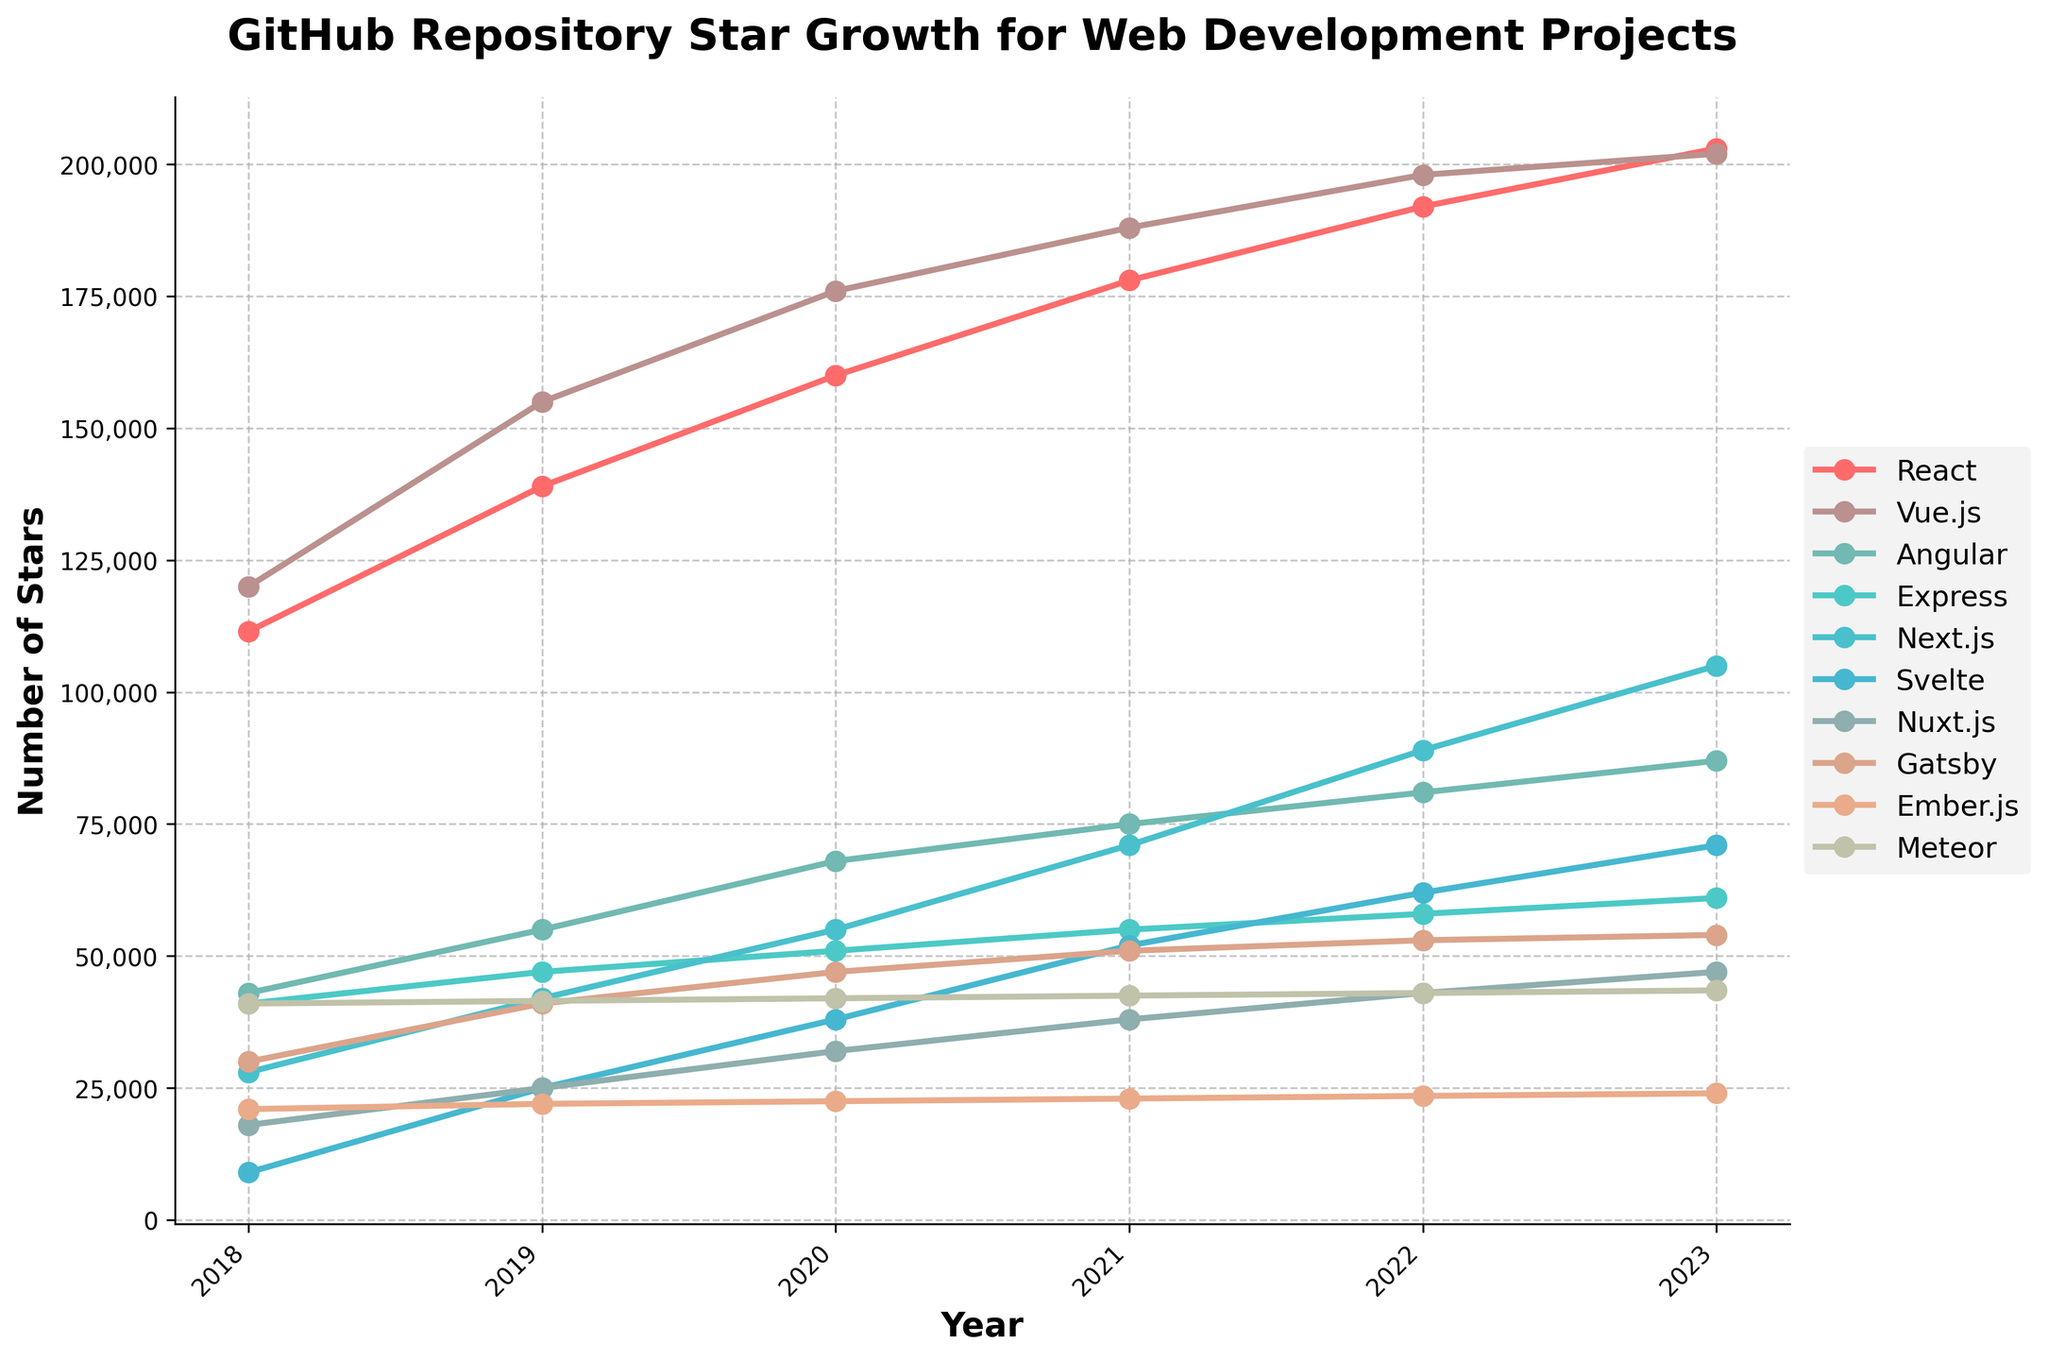Which project had the highest number of stars in 2023? To determine this, look at the data points for the year 2023 for all projects and identify the one with the highest value. React has 203,000 stars, which is the highest
Answer: React How many stars did Svelte gain from 2018 to 2023? Find the data points of Svelte for 2018 and 2023. Svelte had 9,000 stars in 2018 and 71,000 stars in 2023. The gain is 71,000 - 9,000
Answer: 62,000 Which project showed the steepest growth in stars between 2021 and 2023? Compare the growth for each project between 2021 and 2023 by looking at their data points for these years. Next.js rose from 71,000 to 105,000, which is 34,000 stars, the steepest growth in this period
Answer: Next.js Which two projects had nearly equal numbers of stars in 2023? Look for projects with similar star numbers in 2023. React has 203,000 stars, and Vue.js has 202,000, which are very close
Answer: React, Vue.js What is the median number of stars for all projects in 2023? Arrange the number of stars for all projects in 2023 from lowest to highest (24,000; 43,500; 47,000; 54,000; 61,000; 71,000; 87,000; 105,000; 202,000; 203,000) and find the middle value. Since there are 10 projects, the median is the average of the 5th and 6th values, which are 61,000 and 71,000
Answer: 66,000 By how many stars did Vue.js increase from 2018 to 2019? Look at Vue.js's star numbers for 2018 and 2019. It had 120,000 stars in 2018 and 155,000 in 2019. The increase is 155,000 - 120,000
Answer: 35,000 Which project had the least growth from 2018 to 2023? Calculate the growth from 2018 to 2023 for each project and identify the smallest one. Ember.js increased from 21,000 to 24,000, which is just 3,000 stars, the smallest growth
Answer: Ember.js Which color represents the project with the lowest stars in 2023? Identify the color assigned to the project with the lowest stars in 2023. Meteor had the lowest stars in 2023, represented by the color used in the plot for Meteor
Answer: Meteor's color Is the number of stars for Next.js in 2023 more than double that of Angular in 2023? Check the star numbers for Next.js and Angular in 2023. Next.js has 105,000 stars, and Angular has 87,000. Double Angular's stars is 174,000, which is not less than 105,000
Answer: No Compare the growth rates of React and Vue.js from 2021 to 2023 Calculate the growth for React and Vue.js. React grew from 178,000 to 203,000 (25,000 stars), and Vue.js grew from 188,000 to 202,000 (14,000 stars). React had a higher growth rate
Answer: React had a higher growth rate 